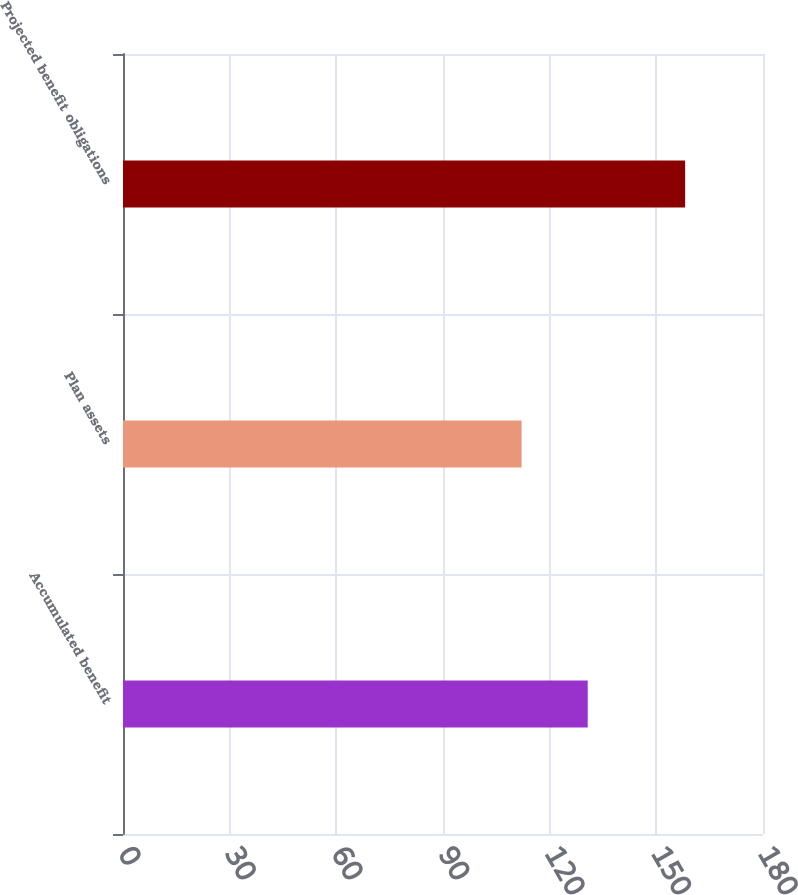<chart> <loc_0><loc_0><loc_500><loc_500><bar_chart><fcel>Accumulated benefit<fcel>Plan assets<fcel>Projected benefit obligations<nl><fcel>130.7<fcel>112.1<fcel>158.1<nl></chart> 